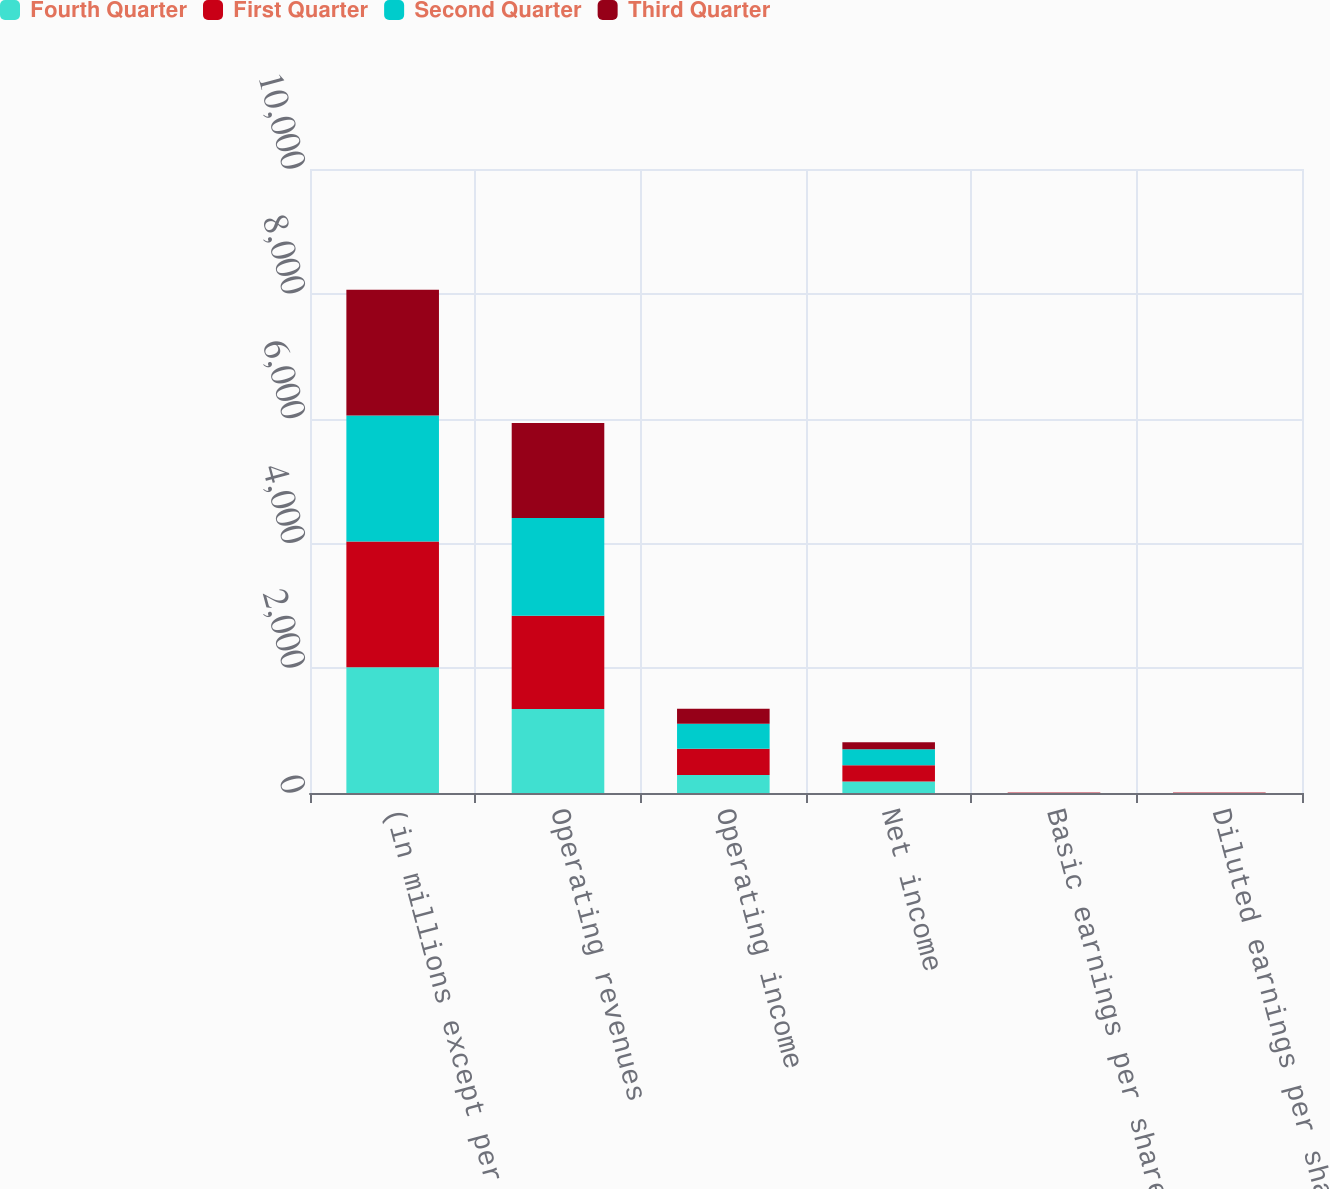<chart> <loc_0><loc_0><loc_500><loc_500><stacked_bar_chart><ecel><fcel>(in millions except per share)<fcel>Operating revenues<fcel>Operating income<fcel>Net income<fcel>Basic earnings per share (a)<fcel>Diluted earnings per share (a)<nl><fcel>Fourth Quarter<fcel>2016<fcel>1347<fcel>290<fcel>184<fcel>1.47<fcel>1.46<nl><fcel>First Quarter<fcel>2016<fcel>1494<fcel>418<fcel>260<fcel>2.11<fcel>2.1<nl><fcel>Second Quarter<fcel>2016<fcel>1566<fcel>400<fcel>256<fcel>2.08<fcel>2.07<nl><fcel>Third Quarter<fcel>2016<fcel>1524<fcel>241<fcel>114<fcel>0.92<fcel>0.92<nl></chart> 